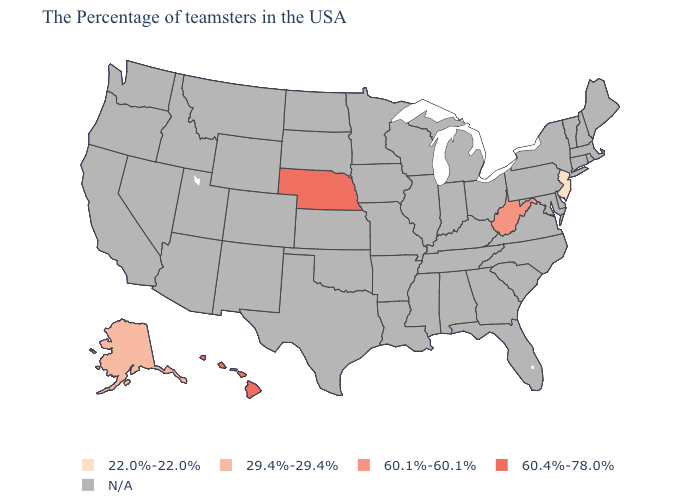Name the states that have a value in the range 29.4%-29.4%?
Answer briefly. Alaska. Name the states that have a value in the range 22.0%-22.0%?
Quick response, please. New Jersey. Name the states that have a value in the range 60.1%-60.1%?
Write a very short answer. West Virginia. Name the states that have a value in the range 60.1%-60.1%?
Short answer required. West Virginia. Which states have the highest value in the USA?
Short answer required. Nebraska, Hawaii. Name the states that have a value in the range 60.4%-78.0%?
Give a very brief answer. Nebraska, Hawaii. Does the map have missing data?
Concise answer only. Yes. Name the states that have a value in the range 60.1%-60.1%?
Keep it brief. West Virginia. What is the value of New York?
Quick response, please. N/A. Name the states that have a value in the range 29.4%-29.4%?
Keep it brief. Alaska. What is the value of Arizona?
Concise answer only. N/A. Which states have the lowest value in the USA?
Give a very brief answer. New Jersey. 